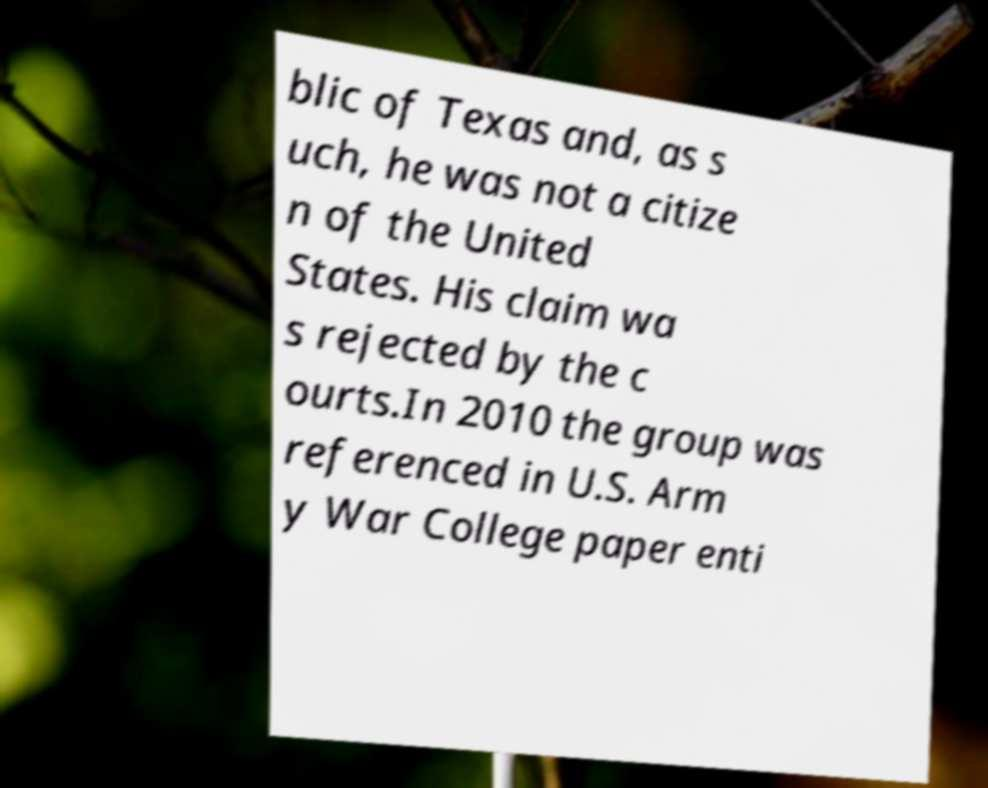For documentation purposes, I need the text within this image transcribed. Could you provide that? blic of Texas and, as s uch, he was not a citize n of the United States. His claim wa s rejected by the c ourts.In 2010 the group was referenced in U.S. Arm y War College paper enti 